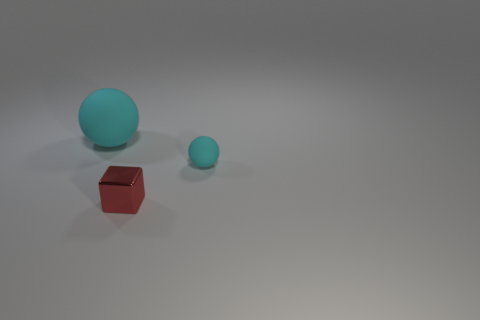What is the shape of the small thing that is the same color as the large matte object?
Give a very brief answer. Sphere. What is the color of the thing that is both behind the tiny metal object and right of the big rubber ball?
Offer a very short reply. Cyan. Are there any tiny matte balls in front of the cyan thing behind the rubber thing that is to the right of the big sphere?
Offer a very short reply. Yes. What number of objects are either spheres or tiny red cubes?
Make the answer very short. 3. Are the big cyan ball and the sphere right of the large sphere made of the same material?
Make the answer very short. Yes. Are there any other things that are the same color as the tiny sphere?
Your response must be concise. Yes. How many things are cyan rubber objects to the right of the metallic cube or cyan balls on the right side of the large sphere?
Provide a short and direct response. 1. There is a thing that is both behind the small red shiny thing and left of the small cyan rubber ball; what shape is it?
Provide a succinct answer. Sphere. There is a rubber sphere that is in front of the big matte ball; what number of big matte things are to the left of it?
Provide a succinct answer. 1. Is there anything else that is the same material as the red thing?
Your response must be concise. No. 